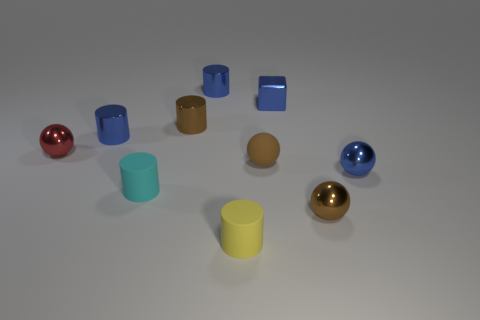Subtract all blue cylinders. How many brown blocks are left? 0 Subtract all matte cylinders. Subtract all small rubber spheres. How many objects are left? 7 Add 5 shiny cylinders. How many shiny cylinders are left? 8 Add 8 tiny blocks. How many tiny blocks exist? 9 Subtract all yellow cylinders. How many cylinders are left? 4 Subtract all blue cylinders. How many cylinders are left? 3 Subtract 0 cyan spheres. How many objects are left? 10 Subtract all balls. How many objects are left? 6 Subtract 1 balls. How many balls are left? 3 Subtract all blue balls. Subtract all purple cylinders. How many balls are left? 3 